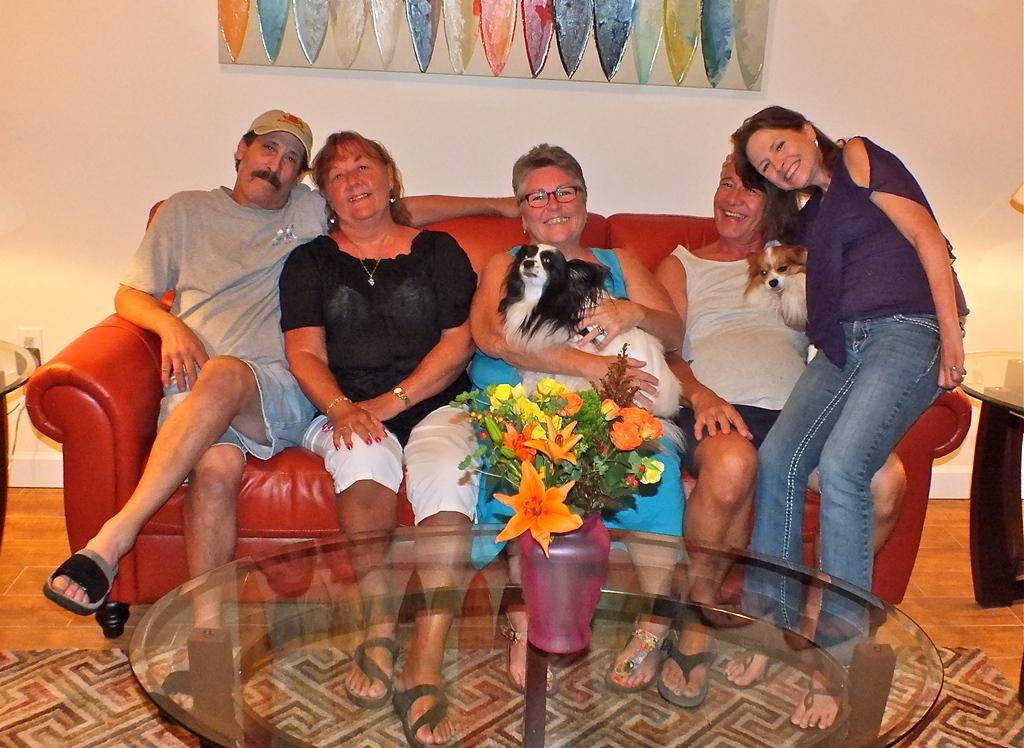What are the people in the image doing? There are people sitting on a sofa in the image. What else can be seen in the image besides the people on the sofa? Some people are holding animals in the image. Can you describe the plant in the image? There is a plant in a vase on a table in the image. What type of boot is being used to stretch the parcel in the image? There is no boot or parcel present in the image. 